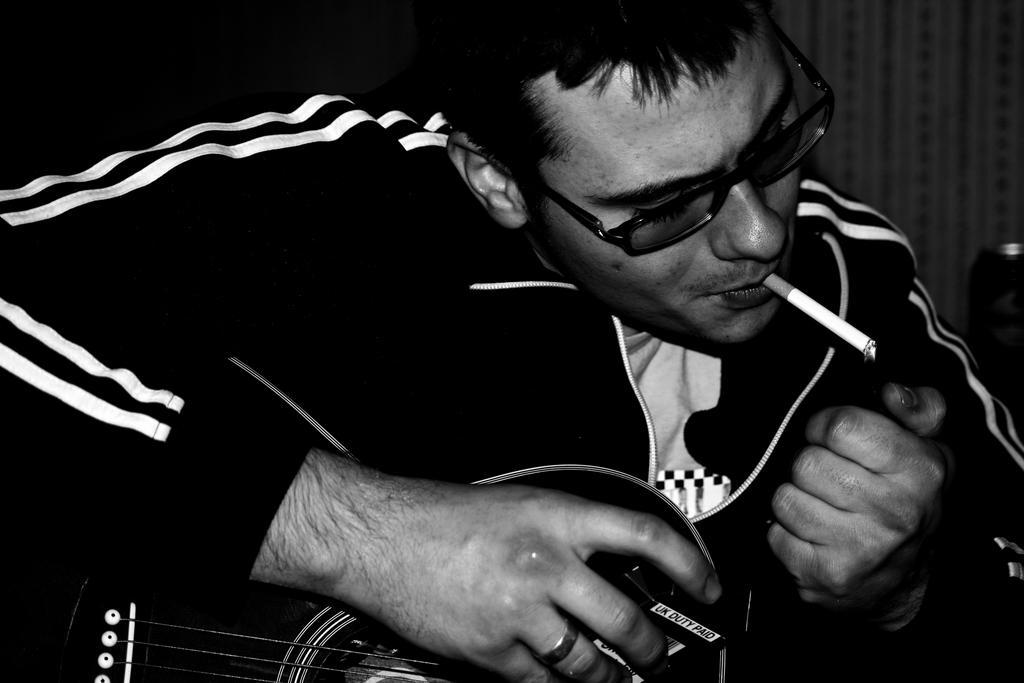In one or two sentences, can you explain what this image depicts? This person kept a cigarette in his mouth and wore spectacles, holding a guitar and holding a box. 